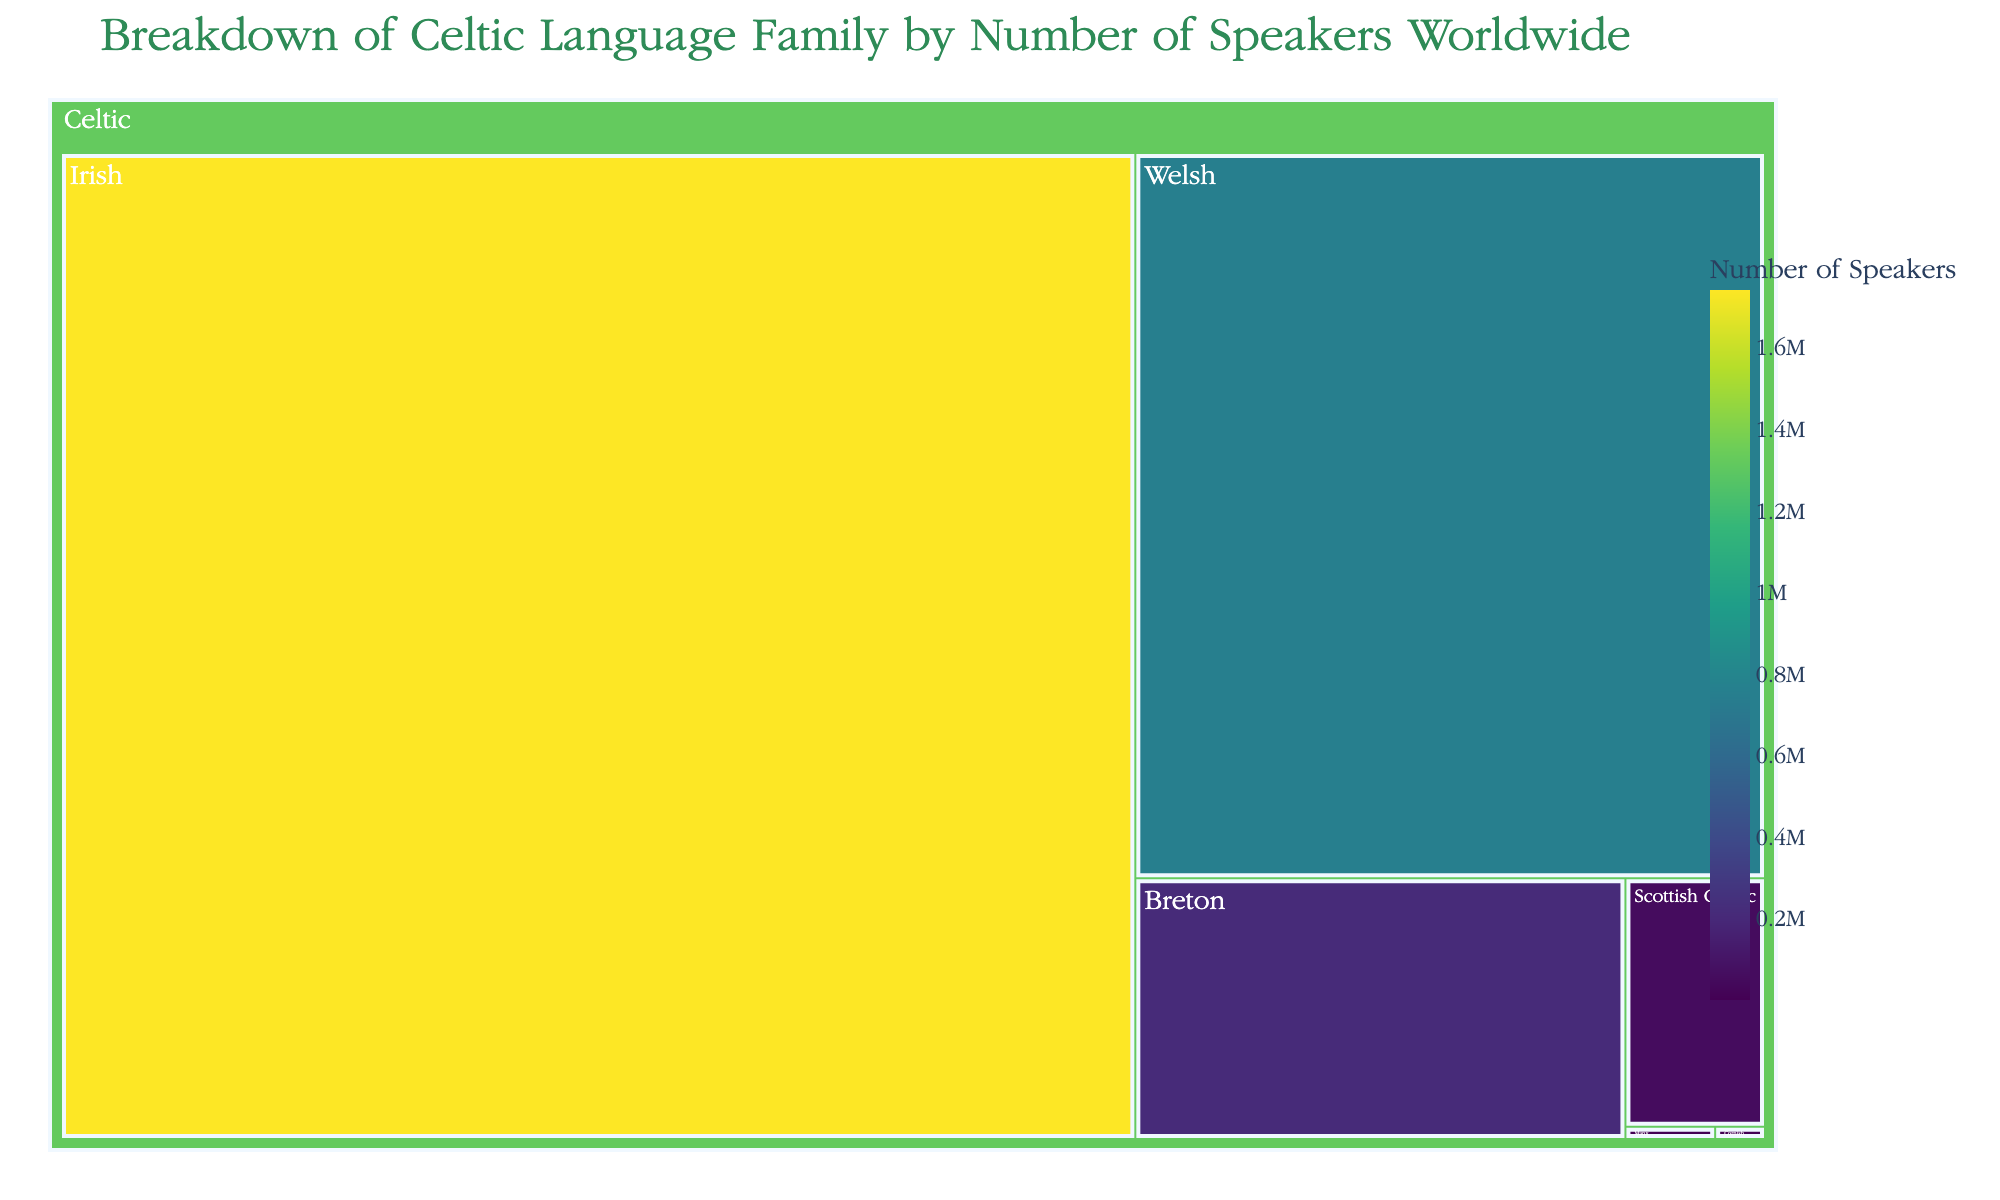What's the title of the treemap? The title is prominently displayed at the top of the treemap.
Answer: Breakdown of Celtic Language Family by Number of Speakers Worldwide Which language has the largest number of speakers? To determine this, look for the largest segment in the treemap. The largest segment represents Irish with 1,740,000 speakers.
Answer: Irish How many speakers does Scottish Gaelic have? Locate the segment labeled Scottish Gaelic and note the number of speakers mentioned.
Answer: 57,000 What is the sum of speakers for Manx and Cornish? Add the number of speakers from the segments labeled Manx (1,800) and Cornish (1,000). 1,800 + 1,000 = 2,800
Answer: 2,800 Which languages have fewer than 100,000 speakers? Identify the segments where the number of speakers is less than 100,000: Scottish Gaelic with 57,000, Manx with 1,800, and Cornish with 1,000.
Answer: Scottish Gaelic, Manx, Cornish Compare the number of speakers of Welsh to Breton. Which one has more, and by how much? Locate both segments and subtract the number of speakers of Breton (210,000) from Welsh (750,000). 750,000 - 210,000 = 540,000
Answer: Welsh by 540,000 What is the combined number of speakers for the languages with more than 500,000 speakers? Identify the segments with more than 500,000 speakers: Irish (1,740,000) and Welsh (750,000). Add them up: 1,740,000 + 750,000 = 2,490,000
Answer: 2,490,000 Which category encompasses all the languages represented in the treemap? Observe the overarching label that covers all segments within the treemap, which is "Celtic".
Answer: Celtic What percentage of the total speakers does Breton make up? First, calculate the total number of speakers: 1,740,000 (Irish) + 750,000 (Welsh) + 210,000 (Breton) + 57,000 (Scottish Gaelic) + 1,800 (Manx) + 1,000 (Cornish) = 2,759,800. Then, divide the number of Breton speakers by the total and multiply by 100. (210,000 / 2,759,800) * 100 ≈ 7.61%
Answer: 7.61% By how much do the speakers of Irish exceed the combined speakers of Manx and Cornish? First, find the combined number of speakers for Manx and Cornish: 1,800 + 1,000 = 2,800. Then, subtract this from the number of Irish speakers: 1,740,000 - 2,800 = 1,737,200
Answer: 1,737,200 